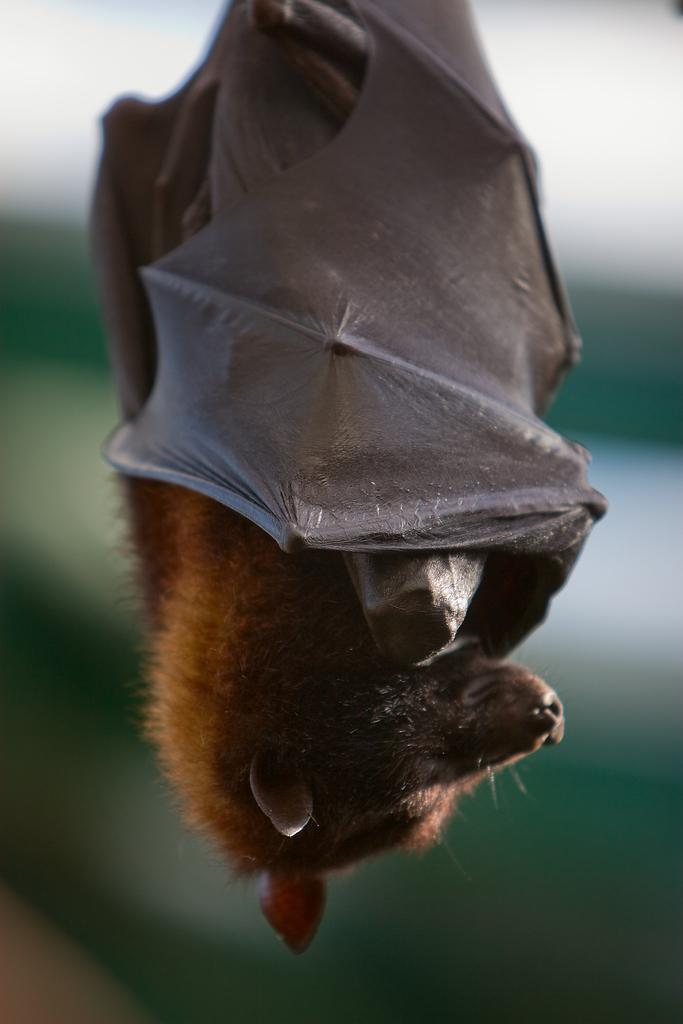What animal is present in the image? There is a bat in the image. How is the bat positioned in the image? The bat is hanging upside down. What type of photography technique is used in the image? The image is a macro photography. What type of pie is being served in the image? There is no pie present in the image; it features a bat hanging upside down. How many eyes does the bat have in the image? The image is not focused on the bat's eyes, but bats typically have two eyes. 